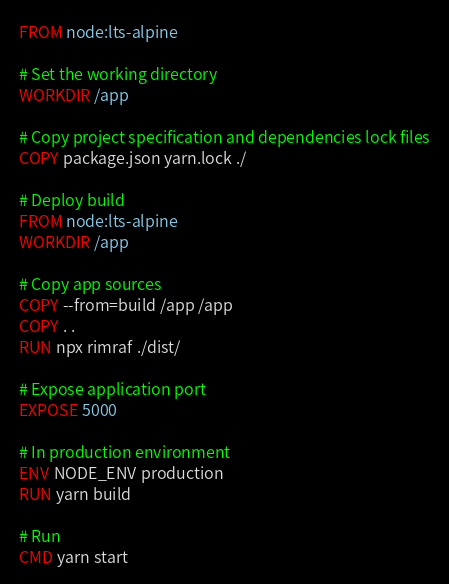<code> <loc_0><loc_0><loc_500><loc_500><_Dockerfile_>FROM node:lts-alpine

# Set the working directory
WORKDIR /app

# Copy project specification and dependencies lock files
COPY package.json yarn.lock ./

# Deploy build
FROM node:lts-alpine
WORKDIR /app

# Copy app sources
COPY --from=build /app /app
COPY . .
RUN npx rimraf ./dist/

# Expose application port
EXPOSE 5000

# In production environment
ENV NODE_ENV production
RUN yarn build

# Run
CMD yarn start</code> 